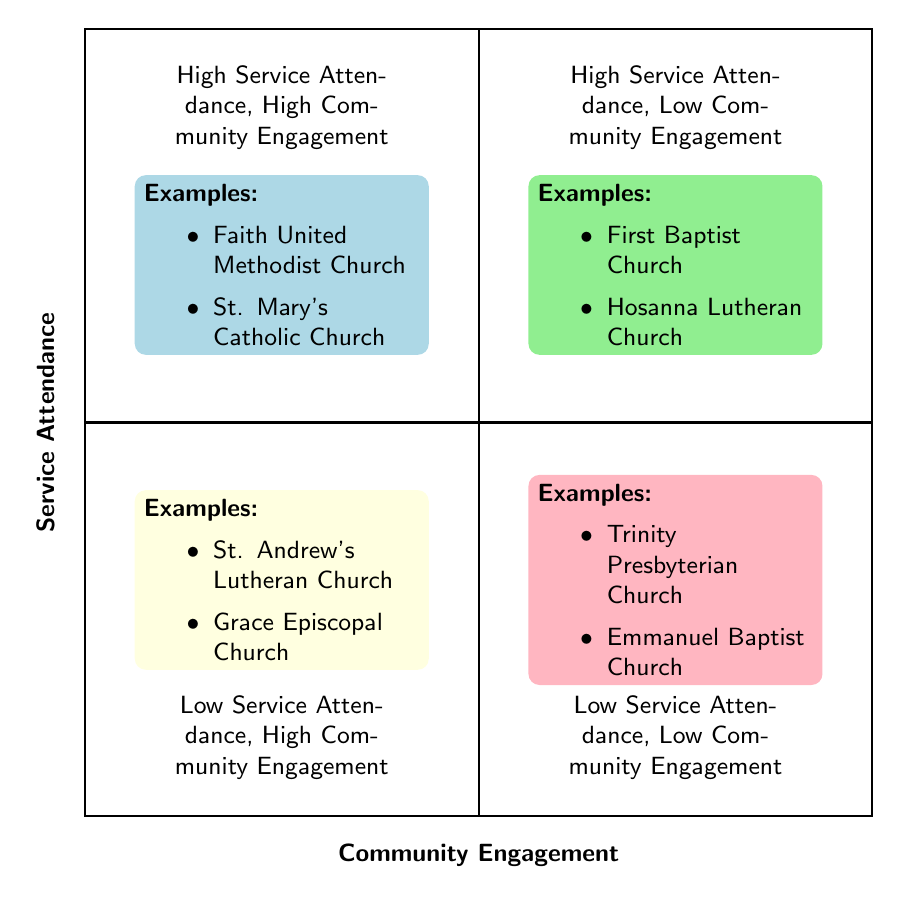What are the examples in the High Service Attendance, High Community Engagement quadrant? The quadrant shows "Faith United Methodist Church" and "St. Mary's Catholic Church" as examples of places with high service attendance and high community engagement.
Answer: Faith United Methodist Church, St. Mary's Catholic Church Which quadrant has examples of churches with low service attendance? The quadrants with low service attendance are "Low Service Attendance, High Community Engagement" and "Low Service Attendance, Low Community Engagement," indicating that both quadrants contain areas where attendance is not high.
Answer: Low Service Attendance, High Community Engagement; Low Service Attendance, Low Community Engagement How many quadrants are identified in this diagram? The diagram clearly indicates four distinct quadrants, which categorize the churches based on their service attendance and community engagement.
Answer: Four Which quadrant would you find churches focused on personal piety? The quadrant labeled "High Service Attendance, Low Community Engagement" describes churches that emphasize personal devotion over community involvement, which includes characteristics focused on personal piety.
Answer: High Service Attendance, Low Community Engagement What are the characteristics of churches in the Low Service Attendance, High Community Engagement quadrant? This quadrant includes characteristics like "Monthly Community Meals," "Interfaith Alliances," and "Seasonal Fundraising Events," which demonstrate active community involvement despite lower attendance.
Answer: Monthly Community Meals, Interfaith Alliances, Seasonal Fundraising Events Which churches are examples of minimal community outreach? The "Low Service Attendance, Low Community Engagement" quadrant contains "Trinity Presbyterian Church" and "Emmanuel Baptist Church," indicating these churches have minimal community outreach activities.
Answer: Trinity Presbyterian Church, Emmanuel Baptist Church What is the relationship between service attendance and community engagement for churches in the High Service Attendance quadrant? The "High Service Attendance" quadrant is split into two sections; one side has high engagement while the other has low engagement, indicating that high attendance does not necessarily correlate with high community involvement.
Answer: High attendance does not guarantee high engagement Name one characteristic found in the Low Service Attendance, Low Community Engagement quadrant. The quadrant lists characteristics like "Sparse Congregations," which illustrates the low participation both in attendance and community activities.
Answer: Sparse Congregations 